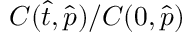Convert formula to latex. <formula><loc_0><loc_0><loc_500><loc_500>C ( \hat { t } , \hat { p } ) / C ( 0 , \hat { p } )</formula> 